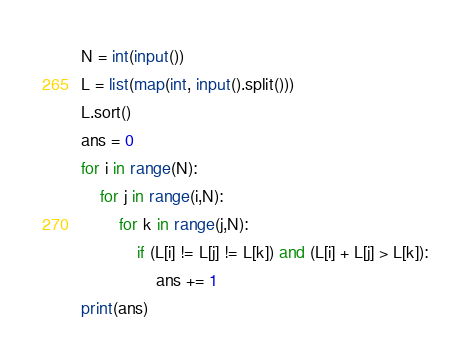Convert code to text. <code><loc_0><loc_0><loc_500><loc_500><_Python_>N = int(input())
L = list(map(int, input().split()))
L.sort()
ans = 0
for i in range(N):
    for j in range(i,N):
        for k in range(j,N):
            if (L[i] != L[j] != L[k]) and (L[i] + L[j] > L[k]):
                ans += 1
print(ans)    </code> 